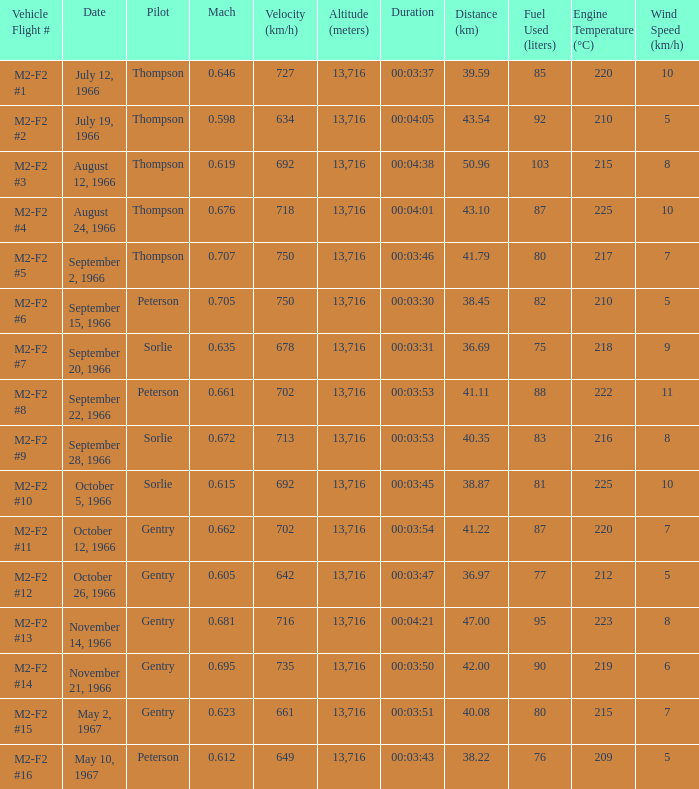What Vehicle Flight # has Pilot Peterson and Velocity (km/h) of 649? M2-F2 #16. 